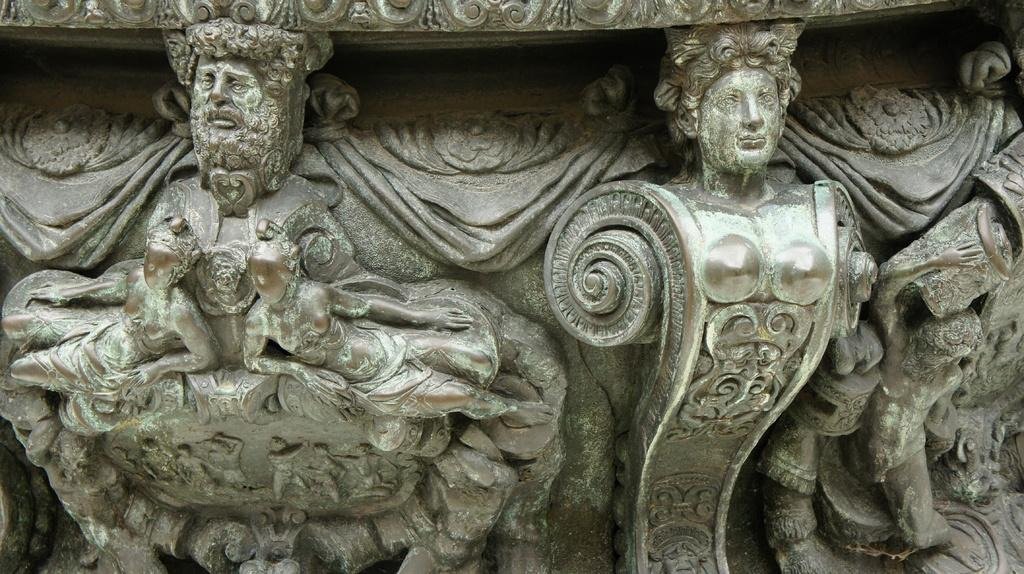What type of objects are depicted in the image? There are two carvings of humans in the image. What material are the carvings made of? The carvings are on a stone. How many ducks are present in the image? There are no ducks present in the image; it features two carvings of humans on a stone. What type of reptile can be seen interacting with the carvings in the image? There are no reptiles, such as lizards, present in the image. 